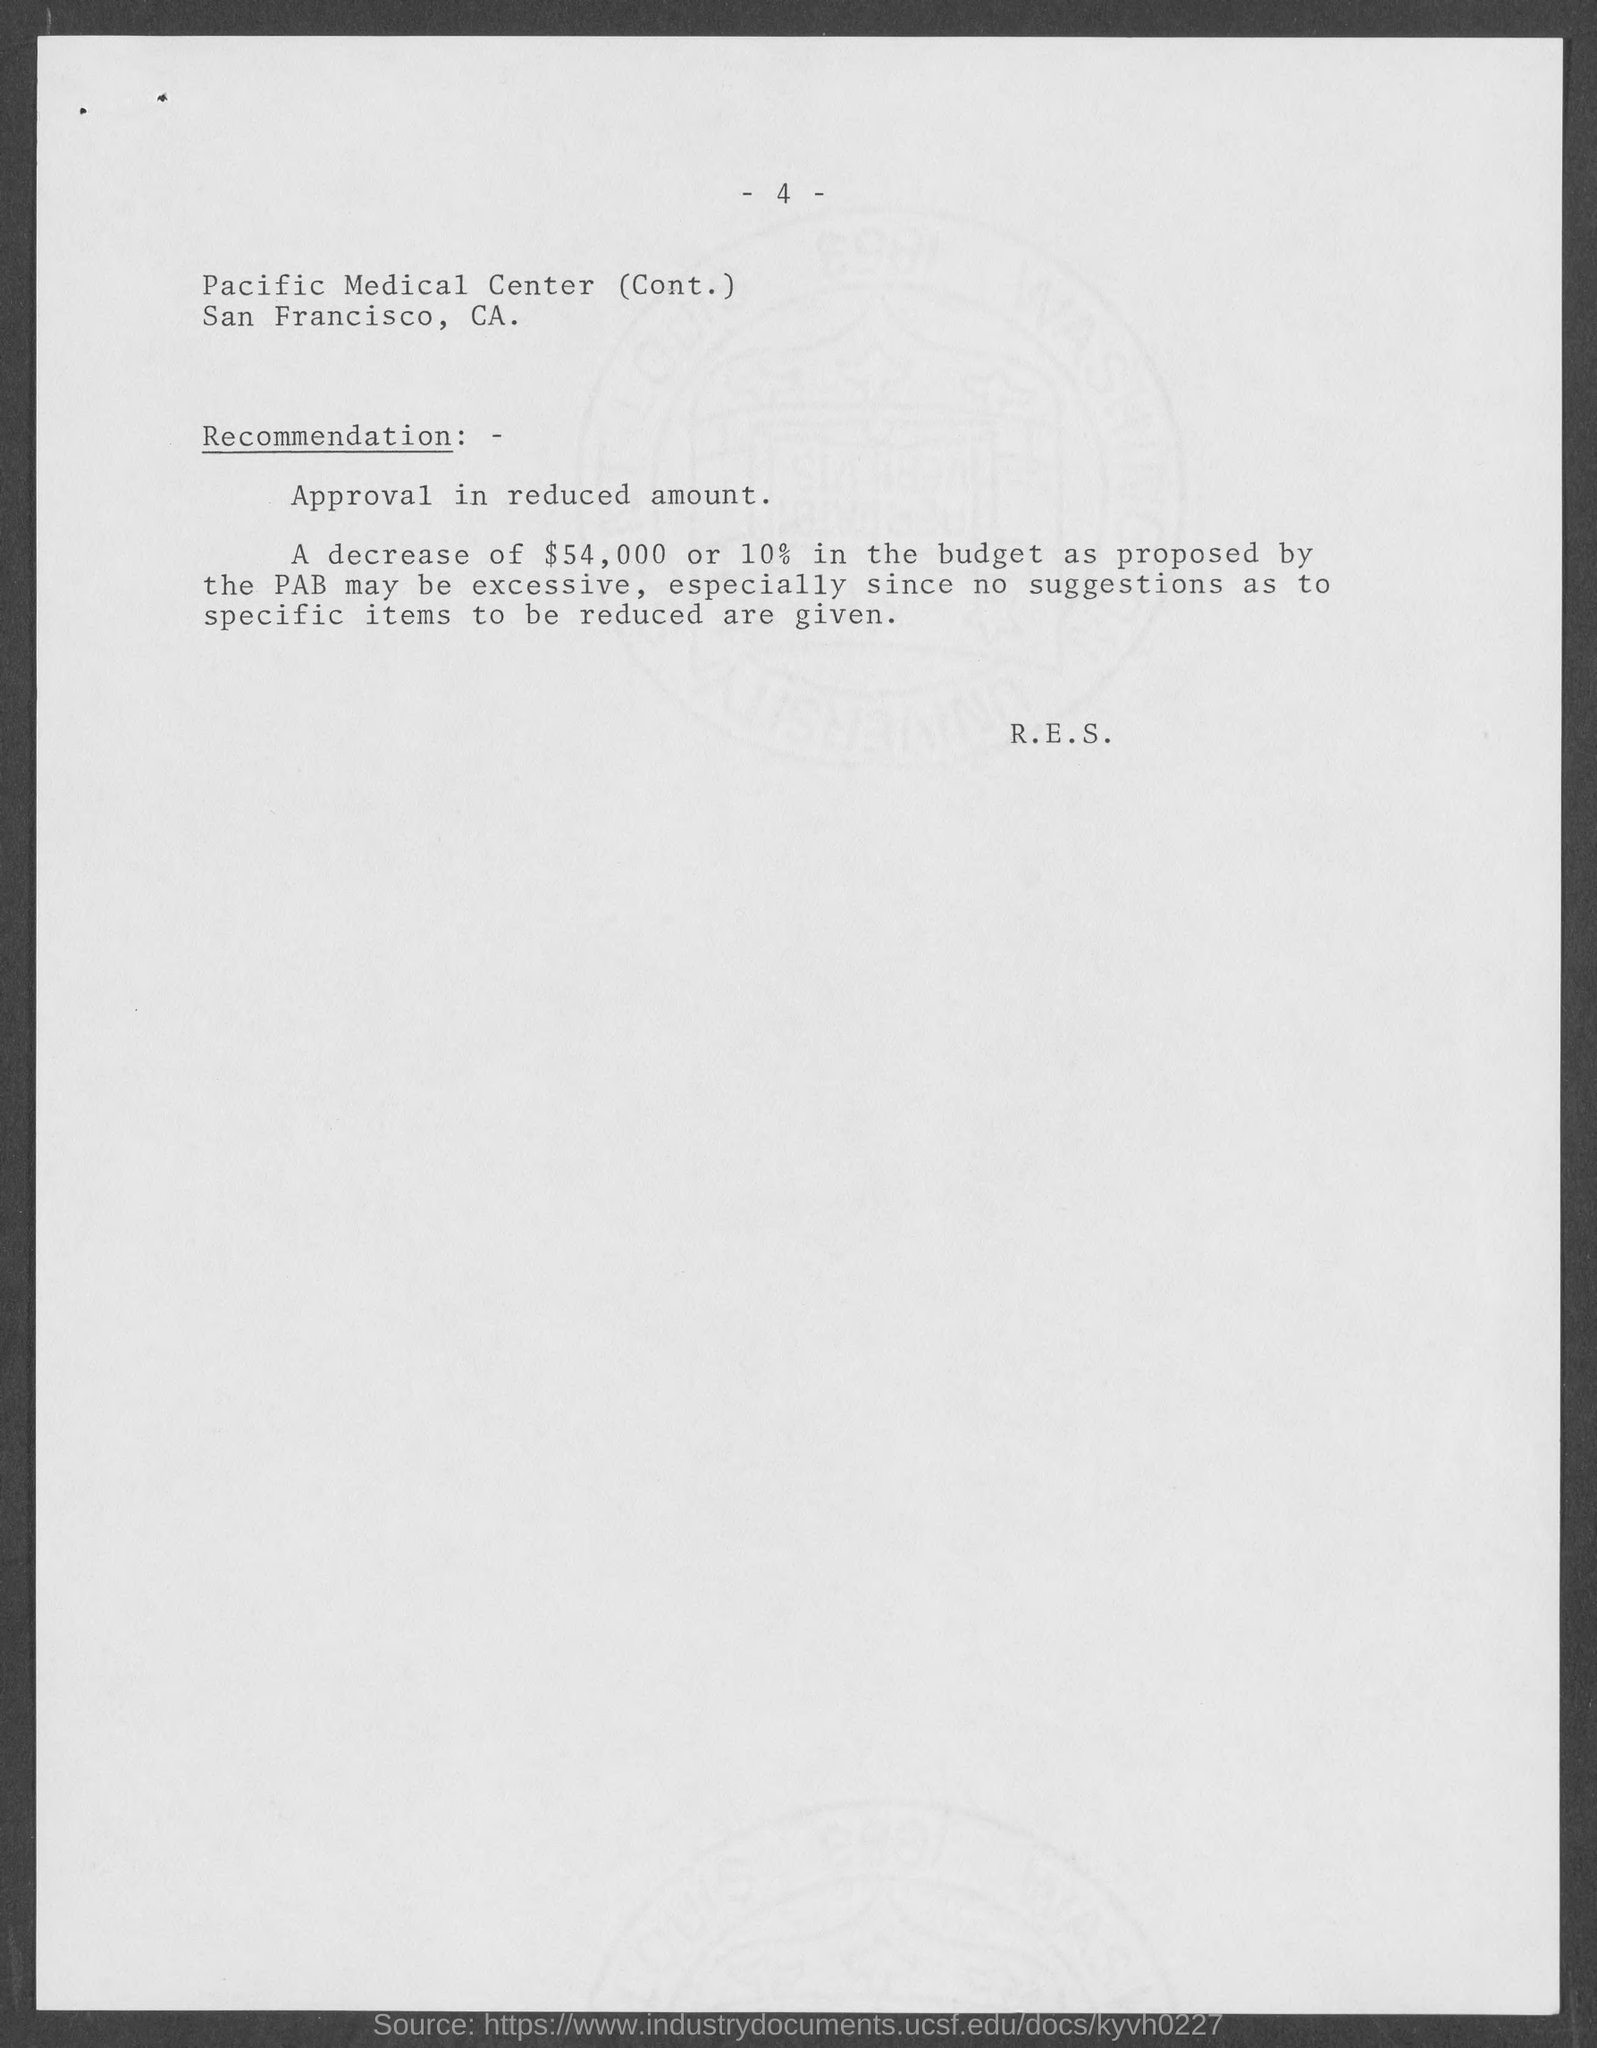What is the page number at top of the page?
Your answer should be compact. 4. In which county is pacific medical center at ?
Give a very brief answer. San Francisco. 